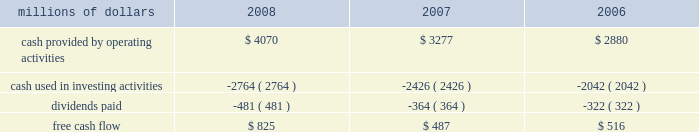Levels during 2008 , an indication that efforts to improve network operations translated into better customer service .
2022 fuel prices 2013 crude oil prices increased at a steady rate through the first seven months of 2008 , closing at a record high of $ 145.29 a barrel in early july .
As the economy worsened during the third and fourth quarters , fuel prices dropped dramatically , hitting $ 33.87 per barrel in december , a near five-year low .
Despite these price declines toward the end of the year , our 2008 average fuel price increased by 39% ( 39 % ) and added $ 1.1 billion of operating expenses compared to 2007 .
Our fuel surcharge programs helped offset the impact of higher fuel prices .
In addition , we reduced our consumption rate by 4% ( 4 % ) , saving approximately 58 million gallons of fuel during the year .
The use of newer , more fuel efficient locomotives ; our fuel conservation programs ; improved network operations ; and a shift in commodity mix , primarily due to growth in bulk shipments , contributed to the improvement .
2022 free cash flow 2013 cash generated by operating activities totaled a record $ 4.1 billion , yielding free cash flow of $ 825 million in 2008 .
Free cash flow is defined as cash provided by operating activities , less cash used in investing activities and dividends paid .
Free cash flow is not considered a financial measure under accounting principles generally accepted in the united states ( gaap ) by sec regulation g and item 10 of sec regulation s-k .
We believe free cash flow is important in evaluating our financial performance and measures our ability to generate cash without additional external financings .
Free cash flow should be considered in addition to , rather than as a substitute for , cash provided by operating activities .
The table reconciles cash provided by operating activities ( gaap measure ) to free cash flow ( non-gaap measure ) : millions of dollars 2008 2007 2006 .
2009 outlook 2022 safety 2013 operating a safe railroad benefits our employees , our customers , our shareholders , and the public .
We will continue using a multi-faceted approach to safety , utilizing technology , risk assessment , quality control , and training and engaging our employees .
We plan to continue implementation of total safety culture ( tsc ) throughout our operations .
Tsc , an employee-focused initiative that has helped improve safety , is a process designed to establish , maintain , and promote safety among co-workers .
With respect to public safety , we will continue our efforts to maintain , upgrade , and close crossings , install video cameras on locomotives , and educate the public about crossing safety through various railroad and industry programs , along with other activities .
2022 transportation plan 2013 in 2009 , we will continue to evaluate traffic flows and network logistic patterns to identify additional opportunities to simplify operations and improve network efficiency and asset utilization .
We plan to maintain adequate manpower and locomotives , and improve productivity using industrial engineering techniques .
2022 fuel prices 2013 on average , we expect fuel prices to decrease substantially from the average price we paid in 2008 .
However , due to economic uncertainty , other global pressures , and weather incidents , fuel prices again could be volatile during the year .
To reduce the impact of fuel price on earnings , we .
What was the percentage change in free cash flow from 2006 to 2007? 
Computations: ((487 - 516) / 516)
Answer: -0.0562. 